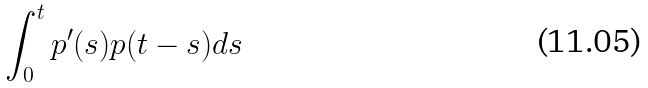<formula> <loc_0><loc_0><loc_500><loc_500>\int _ { 0 } ^ { t } p ^ { \prime } ( s ) p ( t - s ) d s</formula> 